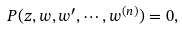Convert formula to latex. <formula><loc_0><loc_0><loc_500><loc_500>P ( z , w , w ^ { \prime } , \cdots , w ^ { ( n ) } ) = 0 ,</formula> 